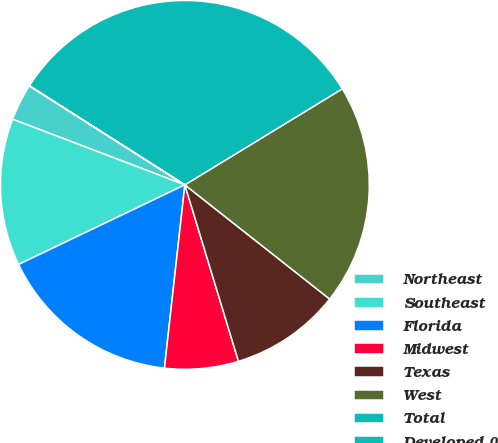Convert chart to OTSL. <chart><loc_0><loc_0><loc_500><loc_500><pie_chart><fcel>Northeast<fcel>Southeast<fcel>Florida<fcel>Midwest<fcel>Texas<fcel>West<fcel>Total<fcel>Developed ()<nl><fcel>3.23%<fcel>12.9%<fcel>16.13%<fcel>6.46%<fcel>9.68%<fcel>19.35%<fcel>32.25%<fcel>0.01%<nl></chart> 